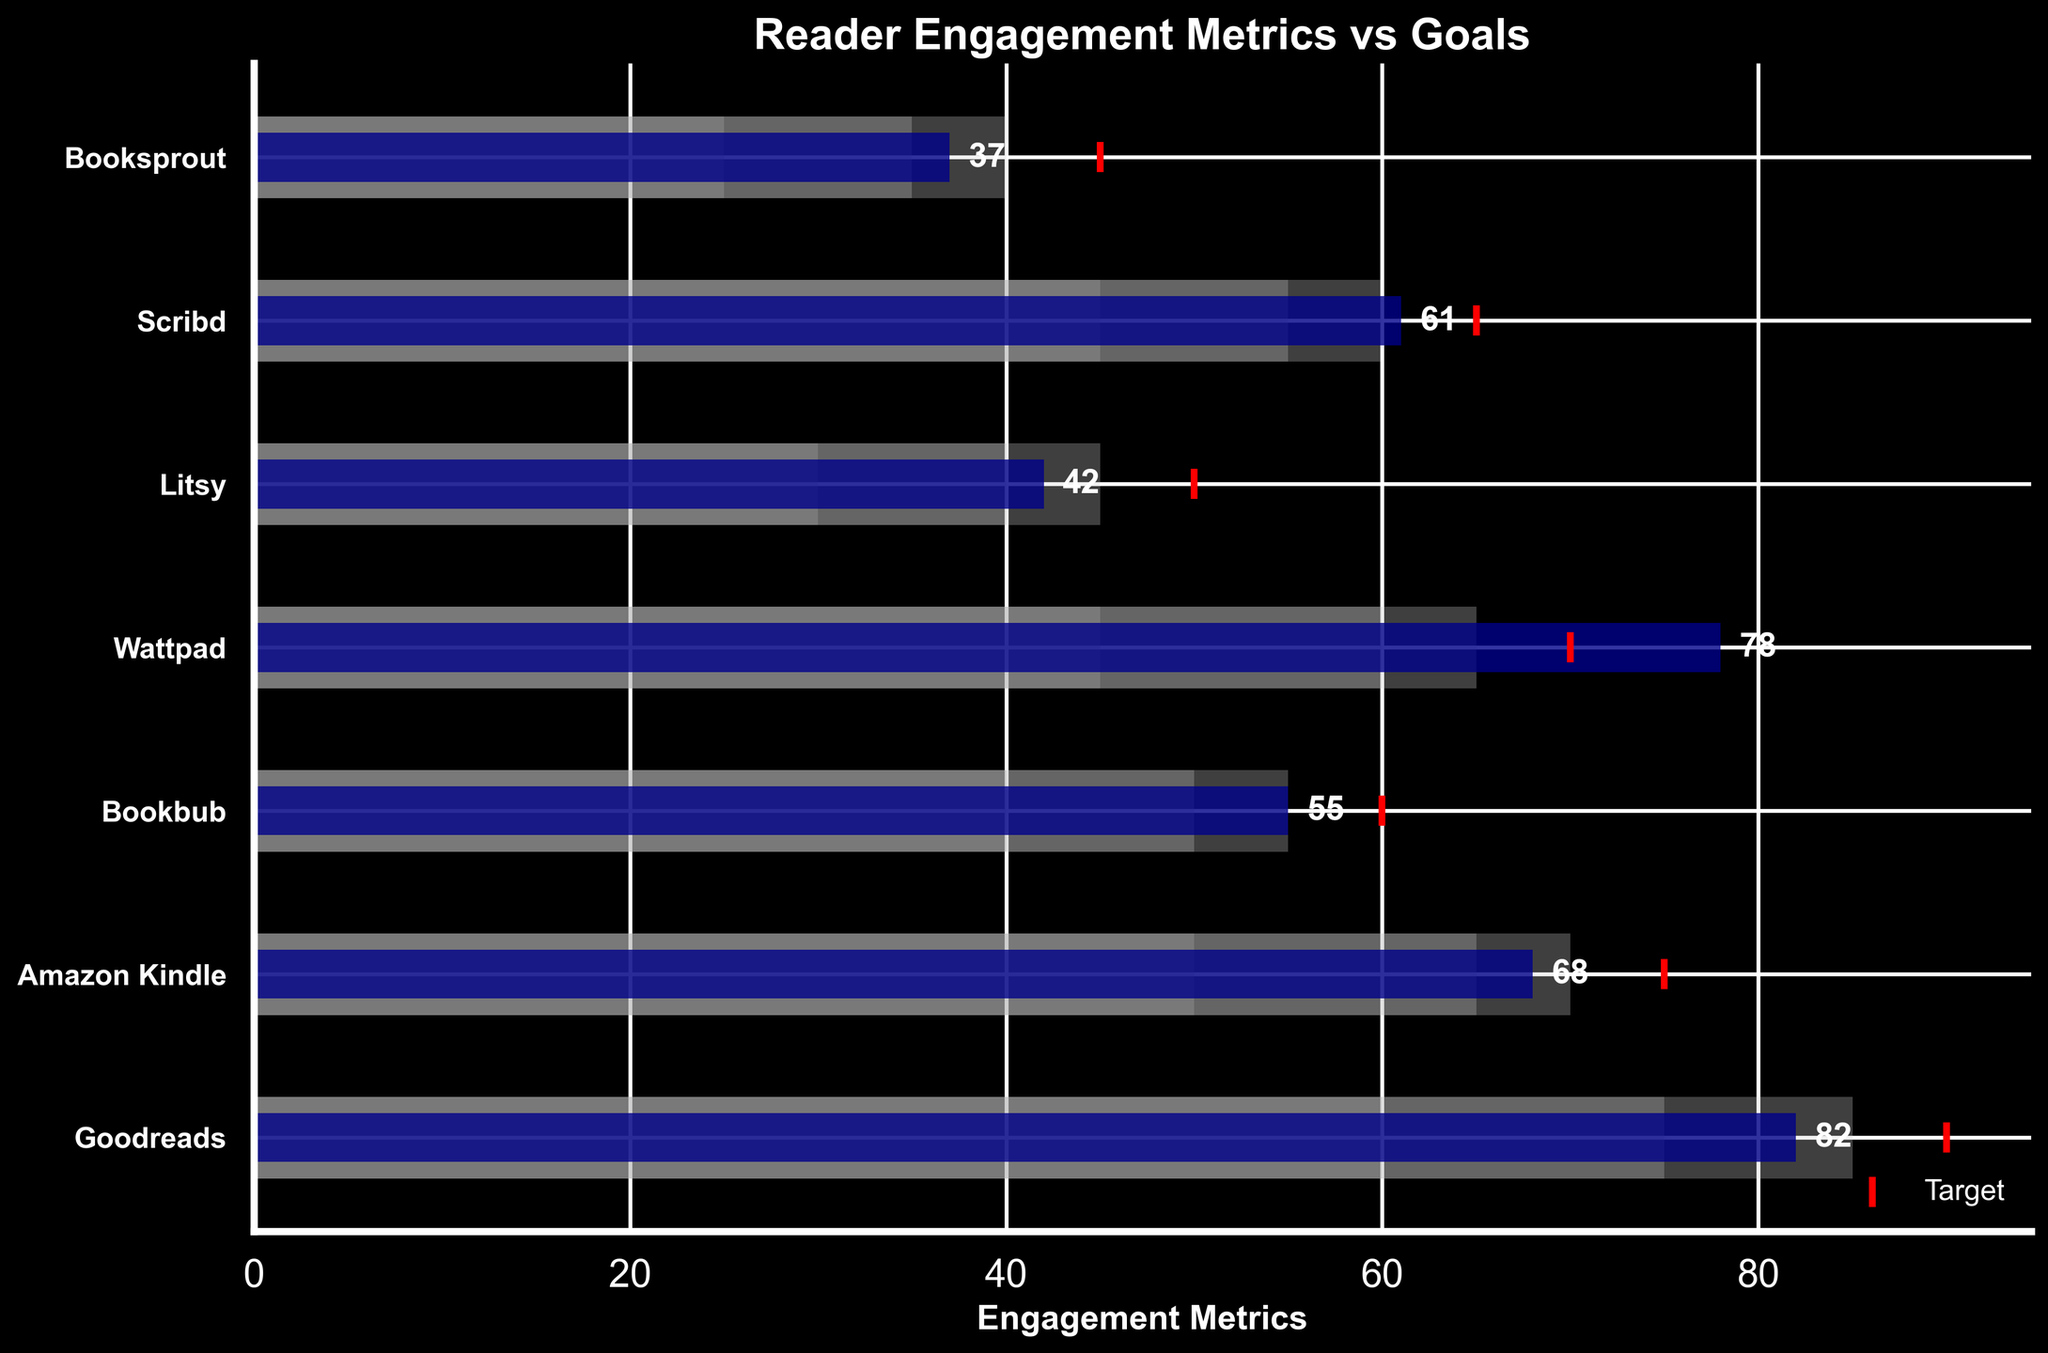What's the title of the figure? The title of the figure is usually found at the top and describes the main topic. Here it is displayed prominently above the chart.
Answer: Reader Engagement Metrics vs Goals Which book platform has the highest actual engagement metric? To find the highest actual engagement metric, look at the actual values from the horizontal bars. The longest bar indicates the highest value.
Answer: Goodreads Which platforms have reached their target engagement metrics? Check if the end of the blue bar (Actual) reaches or exceeds the red vertical line (Target).
Answer: Goodreads and Wattpad What's the difference between the actual and target metrics for Litsy? Subtract the actual metric from the target metric for Litsy. Actual is 42 and Target is 50.
Answer: 8 What's the color representing the 'Poor' performance range? The 'Poor' performance range is represented by the darkest of the background bars.
Answer: Dark grey Rank the platforms from highest to lowest based on their 'Good' performance range. Order the platforms by the 'Good' values displayed for each. Look from the longest to the shortest light grey bars.
Answer: Goodreads, Amazon Kindle, Scribd, Wattpad, Bookbub, Litsy, Booksprout How many platforms have an actual engagement metric lower than their 'Poor' range maximum? Identify platforms where the blue bar (Actual) is shorter than the dark grey bar (Poor).
Answer: None How many platforms have an actual engagement metric greater than their 'Satisfactory' range maximum but less than their 'Good' range maximum? Check the platforms' blue bars (Actual) that fall between the ends of the silver and light grey bars (Satisfactory and Good).
Answer: Two (Amazon Kindle, Bookbub) Which platform has the smallest difference between its actual and target engagement metrics? Calculate the difference for each platform by subtracting their actual metric from their target metric and find the smallest value.
Answer: Wattpad 